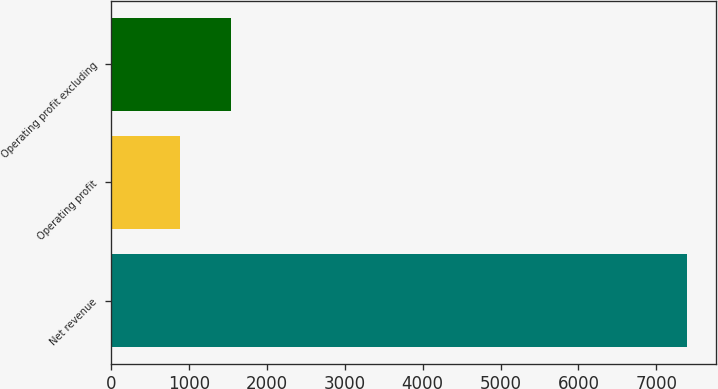Convert chart to OTSL. <chart><loc_0><loc_0><loc_500><loc_500><bar_chart><fcel>Net revenue<fcel>Operating profit<fcel>Operating profit excluding<nl><fcel>7392<fcel>887<fcel>1537.5<nl></chart> 